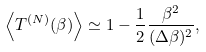Convert formula to latex. <formula><loc_0><loc_0><loc_500><loc_500>\left \langle T ^ { ( N ) } ( \beta ) \right \rangle \simeq 1 - { \frac { 1 } { 2 } } { \frac { \beta ^ { 2 } } { ( \Delta \beta ) ^ { 2 } } } ,</formula> 